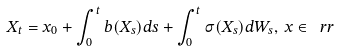Convert formula to latex. <formula><loc_0><loc_0><loc_500><loc_500>X _ { t } = x _ { 0 } + \int _ { 0 } ^ { t } b ( X _ { s } ) d s + \int _ { 0 } ^ { t } \sigma ( X _ { s } ) d W _ { s } , \, x \in \ r r</formula> 